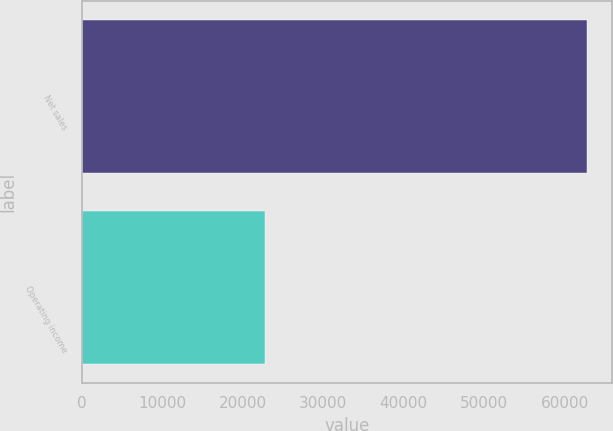<chart> <loc_0><loc_0><loc_500><loc_500><bar_chart><fcel>Net sales<fcel>Operating income<nl><fcel>62739<fcel>22817<nl></chart> 